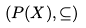Convert formula to latex. <formula><loc_0><loc_0><loc_500><loc_500>( P ( X ) , \subseteq )</formula> 